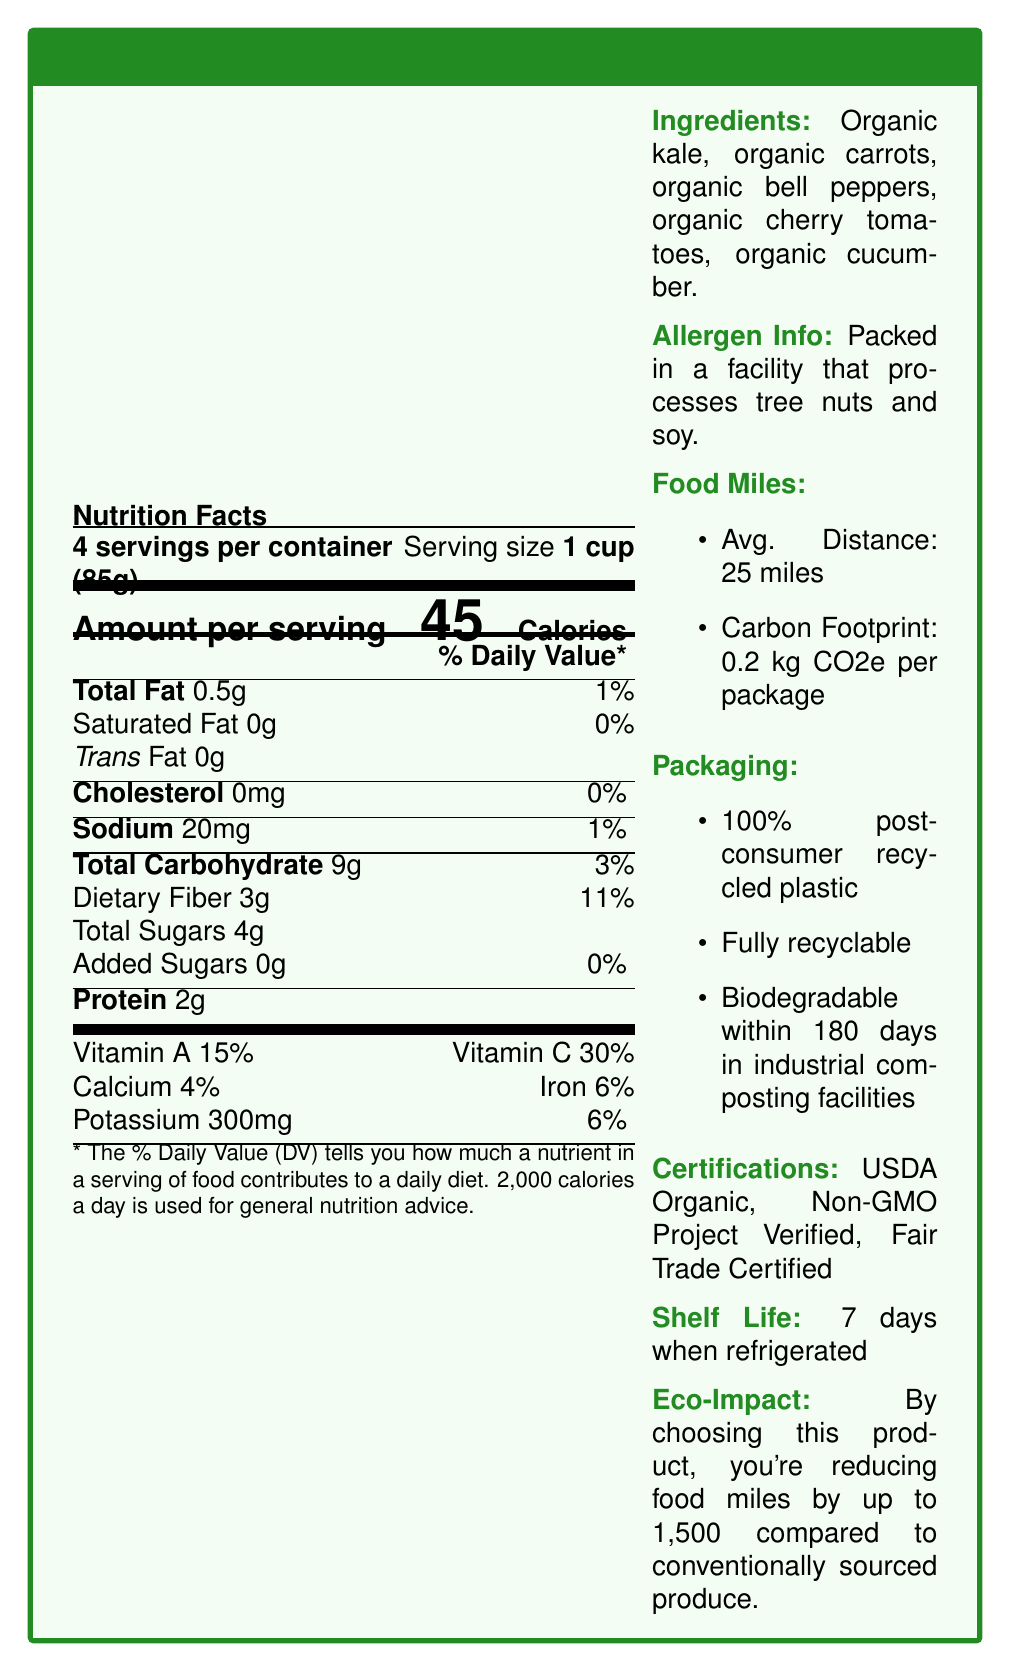what is the serving size? The document states that the serving size is 1 cup (85g).
Answer: 1 cup (85g) what is the main ingredient in the Green Valley Farms Organic Vegetable Blend? The first item listed in the ingredients is organic kale, indicating it is the main ingredient.
Answer: Organic kale how many calories are in one serving of the vegetable blend? The document lists the caloric content per serving as 45 calories.
Answer: 45 what type of plastic is used for the packaging? The packaging section states that the material used is 100% post-consumer recycled plastic.
Answer: 100% post-consumer recycled plastic how long is the shelf life of the product? The document mentions that the shelf life is 7 days when refrigerated.
Answer: 7 days when refrigerated how far does the product travel on average from farm to shelf? A. 10 miles B. 25 miles C. 50 miles The food miles section states that the average distance the product travels is 25 miles.
Answer: B. 25 miles what is the carbon footprint of each package? A. 0.1 kg CO2e B. 0.2 kg CO2e C. 0.5 kg CO2e D. 1 kg CO2e The food miles section indicates that the carbon footprint is 0.2 kg CO2e per package.
Answer: B. 0.2 kg CO2e is the product fair trade certified? The certifications section includes Fair Trade Certified among the listed certifications.
Answer: Yes does the product contain any added sugars? The nutrition facts show that added sugars are 0g, meaning there are no added sugars in the product.
Answer: No name one benefit of purchasing this product mentioned in the psychological appeal section. The psychological appeal section lists "Supporting local farmers reduces food miles and carbon emissions" as a benefit.
Answer: Supporting local farmers reduces food miles and carbon emissions how many total servings are in the container? The document states that there are 4 servings per container.
Answer: 4 identify one eco-friendly practice used by the farms providing this product. The eco-friendly practices section lists water-conserving drip irrigation as one of the practices.
Answer: Water-conserving drip irrigation which vitamins are prominently present in the vegetable blend? The nutrition facts show significant percentages for Vitamin A (15%) and Vitamin C (30%).
Answer: Vitamin A and Vitamin C is the product packaging biodegradable in home composting facilities? The packaging details specify that the product is biodegradable within 180 days in industrial composting facilities, not home composting facilities.
Answer: No summarize the main idea of the document. The document provides detailed nutritional information, packaging and sustainability details, eco-friendly practices, psychological benefits, and certifications highlighting the product's commitment to sustainability and consumer health.
Answer: The Green Valley Farms Organic Vegetable Blend is a locally-sourced, sustainable product with minimal food miles. It is packed in eco-friendly, recyclable, and biodegradable packaging. The blend is nutritious, with low calories and no added sugars, and supports environmental and social sustainability through its certifications and eco-friendly farming practices. what percentage of calories per serving comes from fat? The document provides the total fat (0.5g) and calories per serving (45), but does not provide enough information to calculate the exact percentage of calories from fat.
Answer: Cannot be determined 